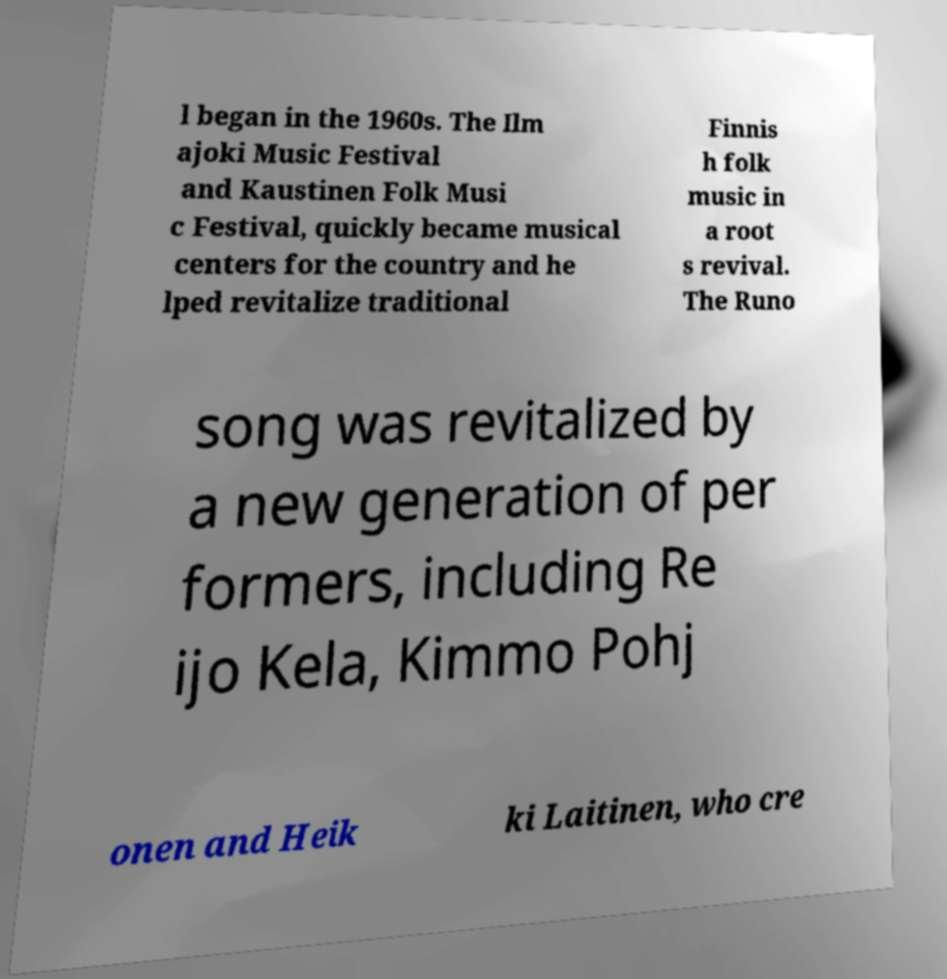Please identify and transcribe the text found in this image. l began in the 1960s. The Ilm ajoki Music Festival and Kaustinen Folk Musi c Festival, quickly became musical centers for the country and he lped revitalize traditional Finnis h folk music in a root s revival. The Runo song was revitalized by a new generation of per formers, including Re ijo Kela, Kimmo Pohj onen and Heik ki Laitinen, who cre 